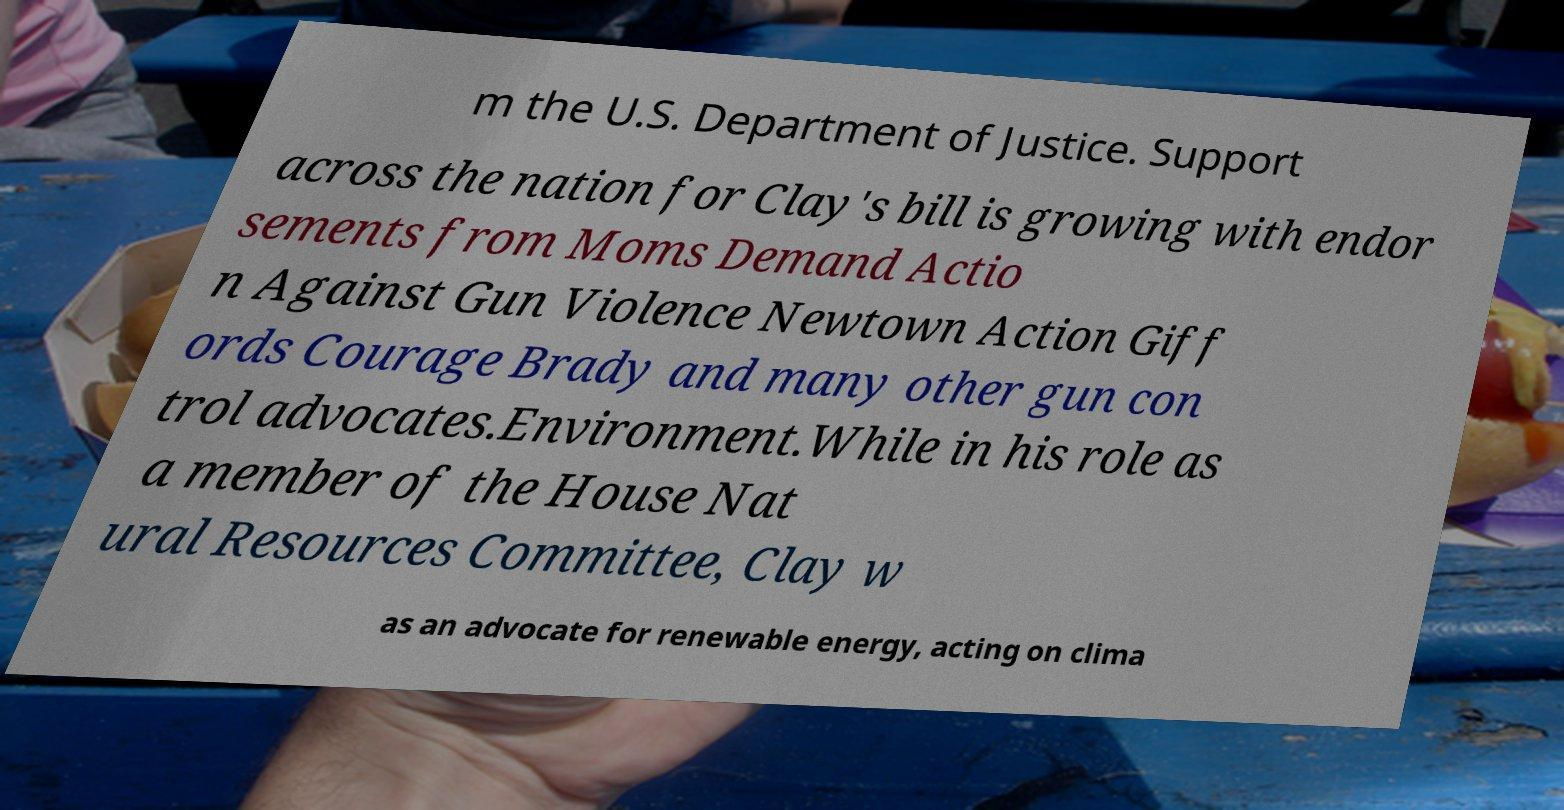Please read and relay the text visible in this image. What does it say? m the U.S. Department of Justice. Support across the nation for Clay's bill is growing with endor sements from Moms Demand Actio n Against Gun Violence Newtown Action Giff ords Courage Brady and many other gun con trol advocates.Environment.While in his role as a member of the House Nat ural Resources Committee, Clay w as an advocate for renewable energy, acting on clima 